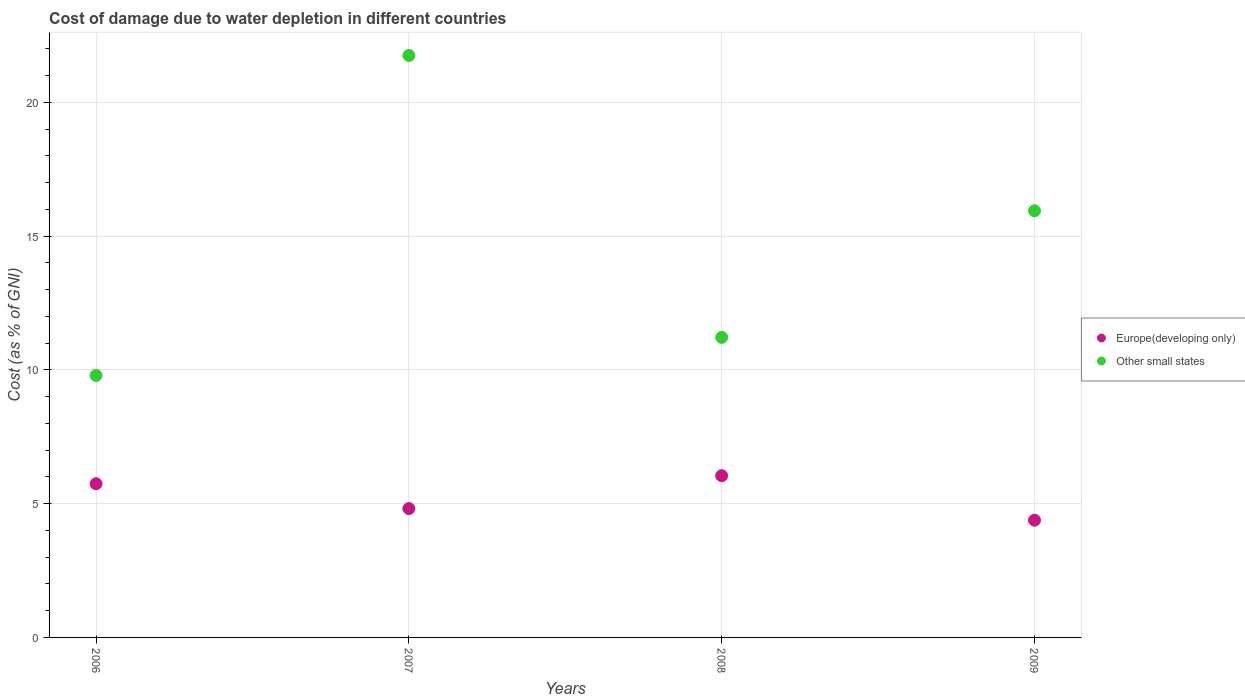How many different coloured dotlines are there?
Make the answer very short. 2. What is the cost of damage caused due to water depletion in Other small states in 2009?
Ensure brevity in your answer.  15.94. Across all years, what is the maximum cost of damage caused due to water depletion in Other small states?
Make the answer very short. 21.75. Across all years, what is the minimum cost of damage caused due to water depletion in Other small states?
Offer a very short reply. 9.79. In which year was the cost of damage caused due to water depletion in Other small states minimum?
Keep it short and to the point. 2006. What is the total cost of damage caused due to water depletion in Europe(developing only) in the graph?
Ensure brevity in your answer.  20.98. What is the difference between the cost of damage caused due to water depletion in Europe(developing only) in 2006 and that in 2008?
Give a very brief answer. -0.3. What is the difference between the cost of damage caused due to water depletion in Europe(developing only) in 2006 and the cost of damage caused due to water depletion in Other small states in 2008?
Keep it short and to the point. -5.47. What is the average cost of damage caused due to water depletion in Other small states per year?
Your answer should be compact. 14.67. In the year 2009, what is the difference between the cost of damage caused due to water depletion in Other small states and cost of damage caused due to water depletion in Europe(developing only)?
Your answer should be compact. 11.56. In how many years, is the cost of damage caused due to water depletion in Other small states greater than 7 %?
Your answer should be compact. 4. What is the ratio of the cost of damage caused due to water depletion in Europe(developing only) in 2006 to that in 2009?
Keep it short and to the point. 1.31. Is the cost of damage caused due to water depletion in Other small states in 2008 less than that in 2009?
Keep it short and to the point. Yes. Is the difference between the cost of damage caused due to water depletion in Other small states in 2007 and 2008 greater than the difference between the cost of damage caused due to water depletion in Europe(developing only) in 2007 and 2008?
Your answer should be compact. Yes. What is the difference between the highest and the second highest cost of damage caused due to water depletion in Europe(developing only)?
Give a very brief answer. 0.3. What is the difference between the highest and the lowest cost of damage caused due to water depletion in Other small states?
Your answer should be very brief. 11.96. Does the cost of damage caused due to water depletion in Other small states monotonically increase over the years?
Give a very brief answer. No. How many years are there in the graph?
Give a very brief answer. 4. What is the difference between two consecutive major ticks on the Y-axis?
Give a very brief answer. 5. Are the values on the major ticks of Y-axis written in scientific E-notation?
Make the answer very short. No. Where does the legend appear in the graph?
Ensure brevity in your answer.  Center right. How are the legend labels stacked?
Give a very brief answer. Vertical. What is the title of the graph?
Provide a succinct answer. Cost of damage due to water depletion in different countries. What is the label or title of the X-axis?
Provide a succinct answer. Years. What is the label or title of the Y-axis?
Provide a short and direct response. Cost (as % of GNI). What is the Cost (as % of GNI) in Europe(developing only) in 2006?
Make the answer very short. 5.74. What is the Cost (as % of GNI) of Other small states in 2006?
Offer a very short reply. 9.79. What is the Cost (as % of GNI) of Europe(developing only) in 2007?
Provide a succinct answer. 4.82. What is the Cost (as % of GNI) of Other small states in 2007?
Offer a terse response. 21.75. What is the Cost (as % of GNI) of Europe(developing only) in 2008?
Offer a very short reply. 6.04. What is the Cost (as % of GNI) of Other small states in 2008?
Make the answer very short. 11.21. What is the Cost (as % of GNI) of Europe(developing only) in 2009?
Offer a very short reply. 4.38. What is the Cost (as % of GNI) of Other small states in 2009?
Offer a terse response. 15.94. Across all years, what is the maximum Cost (as % of GNI) of Europe(developing only)?
Give a very brief answer. 6.04. Across all years, what is the maximum Cost (as % of GNI) in Other small states?
Make the answer very short. 21.75. Across all years, what is the minimum Cost (as % of GNI) in Europe(developing only)?
Your answer should be compact. 4.38. Across all years, what is the minimum Cost (as % of GNI) of Other small states?
Keep it short and to the point. 9.79. What is the total Cost (as % of GNI) of Europe(developing only) in the graph?
Your answer should be very brief. 20.98. What is the total Cost (as % of GNI) of Other small states in the graph?
Offer a terse response. 58.7. What is the difference between the Cost (as % of GNI) of Europe(developing only) in 2006 and that in 2007?
Ensure brevity in your answer.  0.93. What is the difference between the Cost (as % of GNI) in Other small states in 2006 and that in 2007?
Your answer should be very brief. -11.96. What is the difference between the Cost (as % of GNI) of Europe(developing only) in 2006 and that in 2008?
Your answer should be very brief. -0.3. What is the difference between the Cost (as % of GNI) in Other small states in 2006 and that in 2008?
Ensure brevity in your answer.  -1.42. What is the difference between the Cost (as % of GNI) of Europe(developing only) in 2006 and that in 2009?
Provide a succinct answer. 1.36. What is the difference between the Cost (as % of GNI) of Other small states in 2006 and that in 2009?
Give a very brief answer. -6.15. What is the difference between the Cost (as % of GNI) of Europe(developing only) in 2007 and that in 2008?
Provide a succinct answer. -1.23. What is the difference between the Cost (as % of GNI) of Other small states in 2007 and that in 2008?
Keep it short and to the point. 10.53. What is the difference between the Cost (as % of GNI) in Europe(developing only) in 2007 and that in 2009?
Offer a terse response. 0.43. What is the difference between the Cost (as % of GNI) of Other small states in 2007 and that in 2009?
Give a very brief answer. 5.8. What is the difference between the Cost (as % of GNI) in Europe(developing only) in 2008 and that in 2009?
Give a very brief answer. 1.66. What is the difference between the Cost (as % of GNI) in Other small states in 2008 and that in 2009?
Keep it short and to the point. -4.73. What is the difference between the Cost (as % of GNI) of Europe(developing only) in 2006 and the Cost (as % of GNI) of Other small states in 2007?
Provide a succinct answer. -16. What is the difference between the Cost (as % of GNI) in Europe(developing only) in 2006 and the Cost (as % of GNI) in Other small states in 2008?
Offer a terse response. -5.47. What is the difference between the Cost (as % of GNI) in Europe(developing only) in 2006 and the Cost (as % of GNI) in Other small states in 2009?
Provide a short and direct response. -10.2. What is the difference between the Cost (as % of GNI) in Europe(developing only) in 2007 and the Cost (as % of GNI) in Other small states in 2008?
Keep it short and to the point. -6.4. What is the difference between the Cost (as % of GNI) in Europe(developing only) in 2007 and the Cost (as % of GNI) in Other small states in 2009?
Give a very brief answer. -11.13. What is the difference between the Cost (as % of GNI) of Europe(developing only) in 2008 and the Cost (as % of GNI) of Other small states in 2009?
Your response must be concise. -9.9. What is the average Cost (as % of GNI) in Europe(developing only) per year?
Provide a short and direct response. 5.25. What is the average Cost (as % of GNI) of Other small states per year?
Make the answer very short. 14.67. In the year 2006, what is the difference between the Cost (as % of GNI) of Europe(developing only) and Cost (as % of GNI) of Other small states?
Provide a short and direct response. -4.05. In the year 2007, what is the difference between the Cost (as % of GNI) of Europe(developing only) and Cost (as % of GNI) of Other small states?
Your response must be concise. -16.93. In the year 2008, what is the difference between the Cost (as % of GNI) of Europe(developing only) and Cost (as % of GNI) of Other small states?
Offer a very short reply. -5.17. In the year 2009, what is the difference between the Cost (as % of GNI) of Europe(developing only) and Cost (as % of GNI) of Other small states?
Provide a succinct answer. -11.56. What is the ratio of the Cost (as % of GNI) of Europe(developing only) in 2006 to that in 2007?
Offer a very short reply. 1.19. What is the ratio of the Cost (as % of GNI) in Other small states in 2006 to that in 2007?
Your response must be concise. 0.45. What is the ratio of the Cost (as % of GNI) of Europe(developing only) in 2006 to that in 2008?
Provide a short and direct response. 0.95. What is the ratio of the Cost (as % of GNI) in Other small states in 2006 to that in 2008?
Your answer should be compact. 0.87. What is the ratio of the Cost (as % of GNI) in Europe(developing only) in 2006 to that in 2009?
Provide a short and direct response. 1.31. What is the ratio of the Cost (as % of GNI) of Other small states in 2006 to that in 2009?
Your answer should be very brief. 0.61. What is the ratio of the Cost (as % of GNI) in Europe(developing only) in 2007 to that in 2008?
Your answer should be very brief. 0.8. What is the ratio of the Cost (as % of GNI) in Other small states in 2007 to that in 2008?
Provide a succinct answer. 1.94. What is the ratio of the Cost (as % of GNI) in Europe(developing only) in 2007 to that in 2009?
Provide a short and direct response. 1.1. What is the ratio of the Cost (as % of GNI) of Other small states in 2007 to that in 2009?
Provide a succinct answer. 1.36. What is the ratio of the Cost (as % of GNI) in Europe(developing only) in 2008 to that in 2009?
Keep it short and to the point. 1.38. What is the ratio of the Cost (as % of GNI) in Other small states in 2008 to that in 2009?
Ensure brevity in your answer.  0.7. What is the difference between the highest and the second highest Cost (as % of GNI) in Europe(developing only)?
Provide a short and direct response. 0.3. What is the difference between the highest and the second highest Cost (as % of GNI) of Other small states?
Make the answer very short. 5.8. What is the difference between the highest and the lowest Cost (as % of GNI) of Europe(developing only)?
Your answer should be very brief. 1.66. What is the difference between the highest and the lowest Cost (as % of GNI) of Other small states?
Provide a short and direct response. 11.96. 